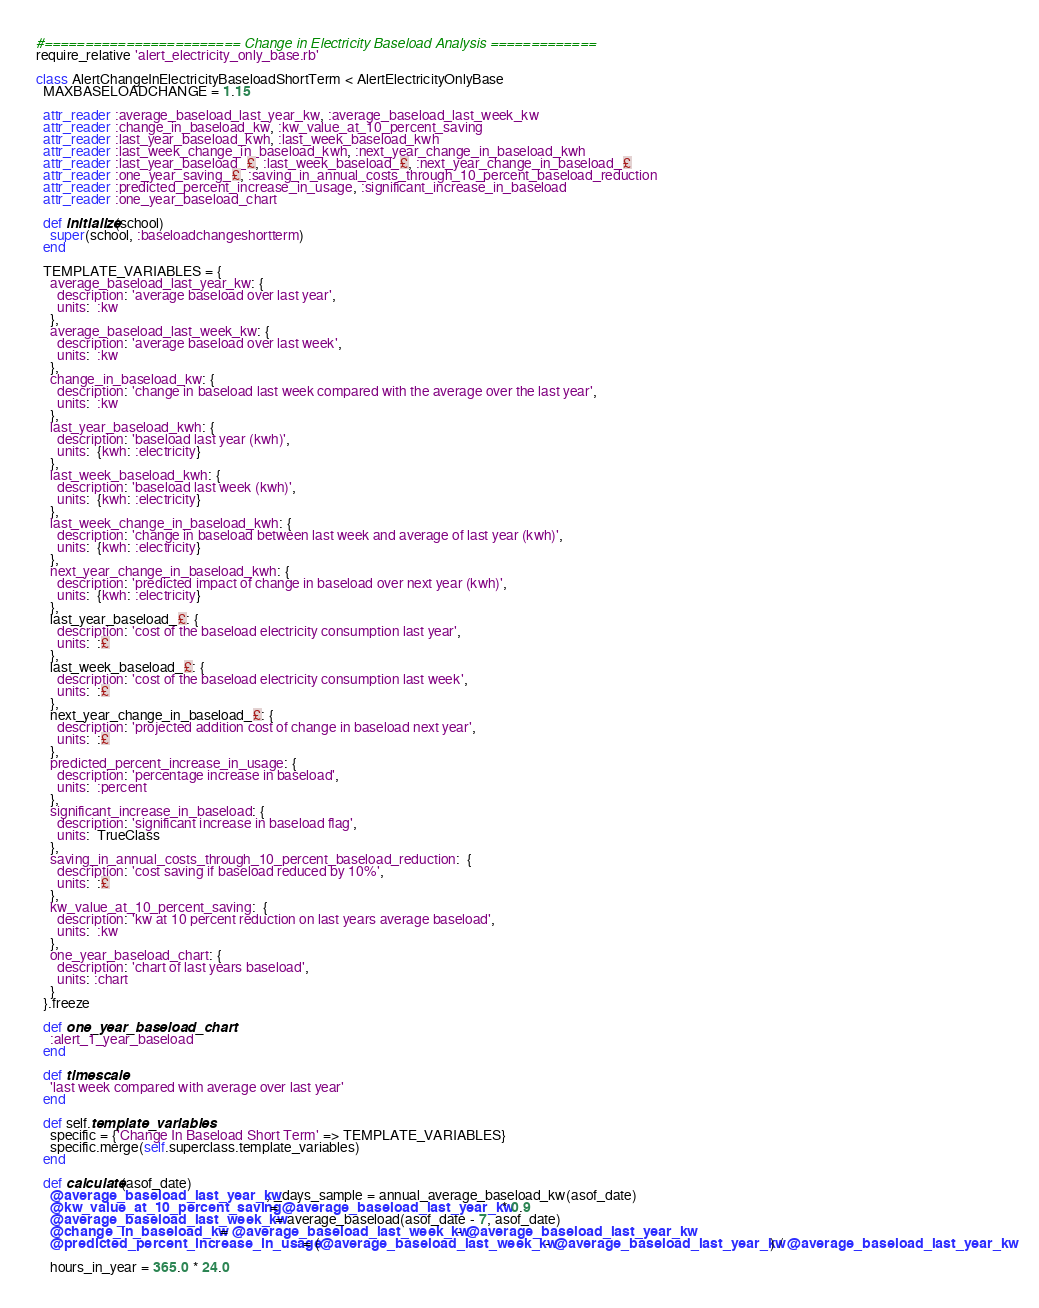<code> <loc_0><loc_0><loc_500><loc_500><_Ruby_>#======================== Change in Electricity Baseload Analysis =============
require_relative 'alert_electricity_only_base.rb'

class AlertChangeInElectricityBaseloadShortTerm < AlertElectricityOnlyBase
  MAXBASELOADCHANGE = 1.15

  attr_reader :average_baseload_last_year_kw, :average_baseload_last_week_kw
  attr_reader :change_in_baseload_kw, :kw_value_at_10_percent_saving
  attr_reader :last_year_baseload_kwh, :last_week_baseload_kwh
  attr_reader :last_week_change_in_baseload_kwh, :next_year_change_in_baseload_kwh
  attr_reader :last_year_baseload_£, :last_week_baseload_£, :next_year_change_in_baseload_£
  attr_reader :one_year_saving_£, :saving_in_annual_costs_through_10_percent_baseload_reduction
  attr_reader :predicted_percent_increase_in_usage, :significant_increase_in_baseload
  attr_reader :one_year_baseload_chart

  def initialize(school)
    super(school, :baseloadchangeshortterm)
  end

  TEMPLATE_VARIABLES = {
    average_baseload_last_year_kw: {
      description: 'average baseload over last year',
      units:  :kw
    },
    average_baseload_last_week_kw: {
      description: 'average baseload over last week',
      units:  :kw
    },
    change_in_baseload_kw: {
      description: 'change in baseload last week compared with the average over the last year',
      units:  :kw
    },
    last_year_baseload_kwh: {
      description: 'baseload last year (kwh)',
      units:  {kwh: :electricity}
    },
    last_week_baseload_kwh: {
      description: 'baseload last week (kwh)',
      units:  {kwh: :electricity}
    },
    last_week_change_in_baseload_kwh: {
      description: 'change in baseload between last week and average of last year (kwh)',
      units:  {kwh: :electricity}
    },
    next_year_change_in_baseload_kwh: {
      description: 'predicted impact of change in baseload over next year (kwh)',
      units:  {kwh: :electricity}
    },
    last_year_baseload_£: {
      description: 'cost of the baseload electricity consumption last year',
      units:  :£
    },
    last_week_baseload_£: {
      description: 'cost of the baseload electricity consumption last week',
      units:  :£
    },
    next_year_change_in_baseload_£: {
      description: 'projected addition cost of change in baseload next year',
      units:  :£
    },
    predicted_percent_increase_in_usage: {
      description: 'percentage increase in baseload',
      units:  :percent
    },
    significant_increase_in_baseload: {
      description: 'significant increase in baseload flag',
      units:  TrueClass
    },
    saving_in_annual_costs_through_10_percent_baseload_reduction:  {
      description: 'cost saving if baseload reduced by 10%',
      units:  :£
    },
    kw_value_at_10_percent_saving:  {
      description: 'kw at 10 percent reduction on last years average baseload',
      units:  :kw
    },
    one_year_baseload_chart: {
      description: 'chart of last years baseload',
      units: :chart
    }
  }.freeze

  def one_year_baseload_chart
    :alert_1_year_baseload
  end

  def timescale
    'last week compared with average over last year'
  end

  def self.template_variables
    specific = {'Change In Baseload Short Term' => TEMPLATE_VARIABLES}
    specific.merge(self.superclass.template_variables)
  end

  def calculate(asof_date)
    @average_baseload_last_year_kw, _days_sample = annual_average_baseload_kw(asof_date)
    @kw_value_at_10_percent_saving = @average_baseload_last_year_kw * 0.9
    @average_baseload_last_week_kw = average_baseload(asof_date - 7, asof_date)
    @change_in_baseload_kw = @average_baseload_last_week_kw - @average_baseload_last_year_kw
    @predicted_percent_increase_in_usage = (@average_baseload_last_week_kw - @average_baseload_last_year_kw) / @average_baseload_last_year_kw

    hours_in_year = 365.0 * 24.0</code> 